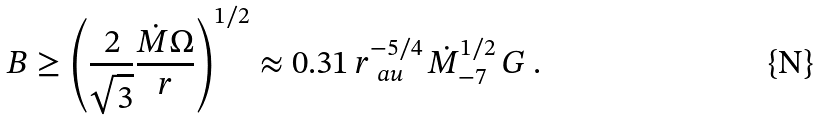<formula> <loc_0><loc_0><loc_500><loc_500>B \geq \left ( \frac { 2 } { \sqrt { 3 } } \frac { \dot { M } \Omega } { r } \right ) ^ { 1 / 2 } \approx 0 . 3 1 \, r _ { \ a u } ^ { - 5 / 4 } \, \dot { M } _ { - 7 } ^ { 1 / 2 } \, G \ .</formula> 